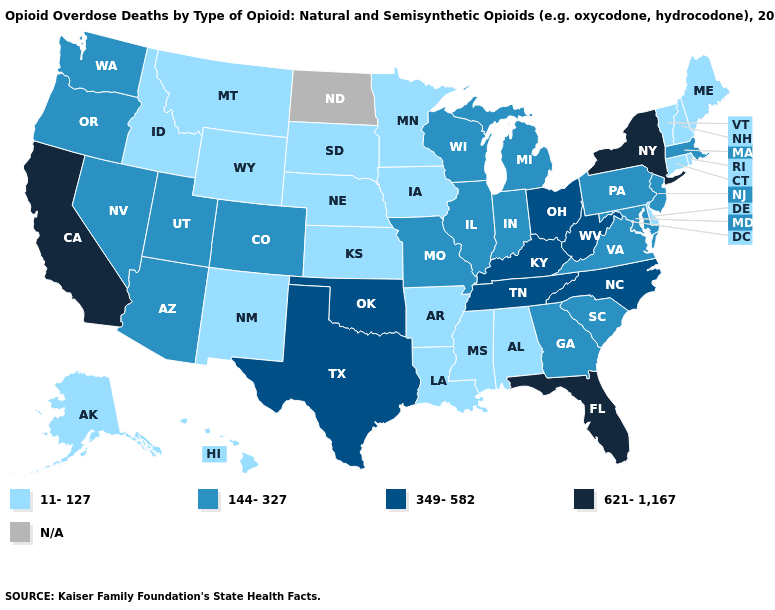What is the highest value in the USA?
Write a very short answer. 621-1,167. Name the states that have a value in the range 349-582?
Write a very short answer. Kentucky, North Carolina, Ohio, Oklahoma, Tennessee, Texas, West Virginia. What is the value of South Carolina?
Quick response, please. 144-327. Name the states that have a value in the range 11-127?
Write a very short answer. Alabama, Alaska, Arkansas, Connecticut, Delaware, Hawaii, Idaho, Iowa, Kansas, Louisiana, Maine, Minnesota, Mississippi, Montana, Nebraska, New Hampshire, New Mexico, Rhode Island, South Dakota, Vermont, Wyoming. Does Ohio have the highest value in the MidWest?
Keep it brief. Yes. Among the states that border Illinois , which have the lowest value?
Write a very short answer. Iowa. How many symbols are there in the legend?
Short answer required. 5. What is the value of Wyoming?
Short answer required. 11-127. What is the value of Idaho?
Short answer required. 11-127. What is the lowest value in the USA?
Concise answer only. 11-127. Name the states that have a value in the range 349-582?
Give a very brief answer. Kentucky, North Carolina, Ohio, Oklahoma, Tennessee, Texas, West Virginia. Does California have the highest value in the USA?
Short answer required. Yes. Among the states that border Kansas , does Oklahoma have the lowest value?
Be succinct. No. 